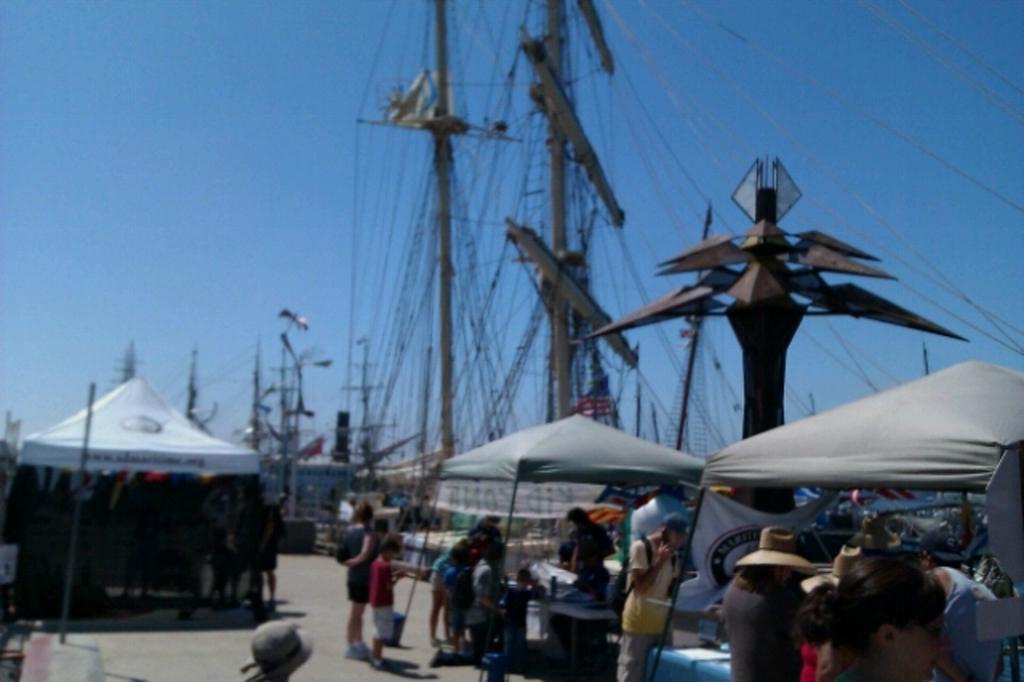Could you give a brief overview of what you see in this image? This image is taken outdoors. At the top of the image there is the sky. At the bottom of the image there is a floor. In the background there are many poles and ropes. There are a few objects. On the left side of the image there is a tent and there are a few people standing on the floor. There is a pole. On the right side of the image there is an architecture. There are two tents and there are two banners with text on them. There are a few tables with many things on them. Many people are standing on the floor. 